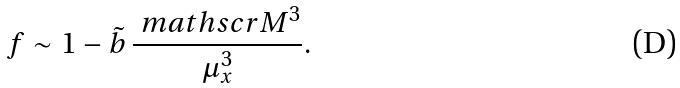Convert formula to latex. <formula><loc_0><loc_0><loc_500><loc_500>f \sim 1 - \tilde { b } \, \frac { \ m a t h s c r { M } ^ { 3 } } { \mu _ { x } ^ { 3 } } .</formula> 